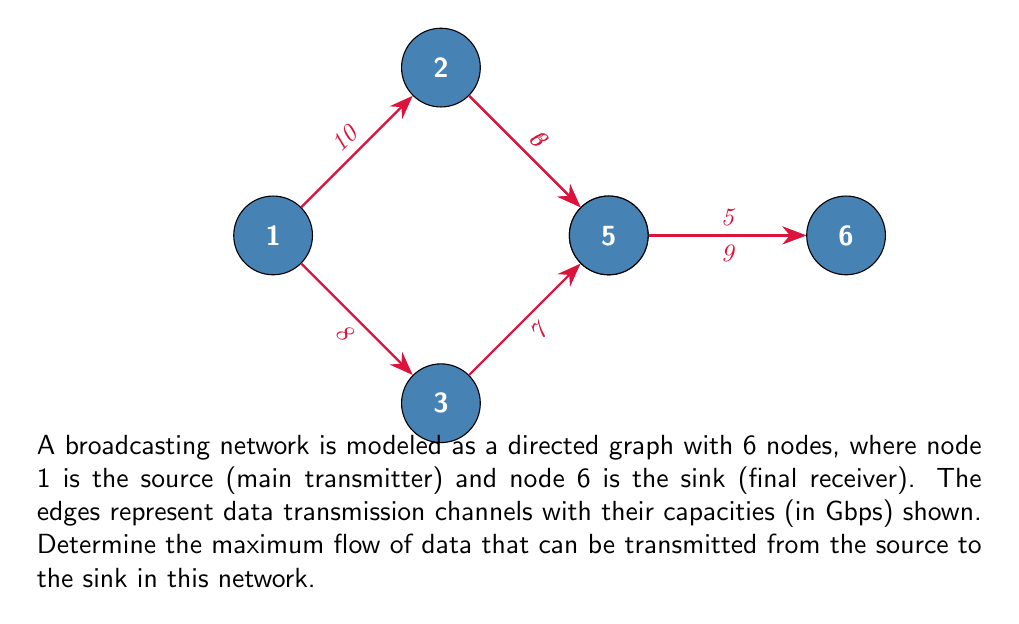Could you help me with this problem? To solve this maximum flow problem, we can use the Ford-Fulkerson algorithm or its improved version, the Edmonds-Karp algorithm. Here's a step-by-step solution:

1) Initialize the flow to 0 for all edges.

2) Find an augmenting path from source to sink. We can use BFS for this (Edmonds-Karp approach). Let's go through the paths:

   Path 1: 1 -> 2 -> 4 -> 6
   Bottleneck: min(10, 6, 5) = 5
   Update flow: 5

   Path 2: 1 -> 2 -> 5 -> 6
   Bottleneck: min(10-5, 3, 9) = 3
   Update flow: 5 + 3 = 8

   Path 3: 1 -> 3 -> 5 -> 6
   Bottleneck: min(8, 7, 9-3) = 6
   Update flow: 8 + 6 = 14

3) No more augmenting paths exist. The maximum flow is 14 Gbps.

To verify:
- Flow out of source: 8 (to node 2) + 6 (to node 3) = 14
- Flow into sink: 5 (from node 4) + 9 (from node 5) = 14

The max-flow min-cut theorem states that the maximum flow is equal to the capacity of the minimum cut. In this case, the minimum cut would be the edges (2,4), (2,5), and (3,5), which have a total capacity of 6 + 3 + 7 = 16 Gbps. Our max flow of 14 Gbps is indeed less than or equal to this cut capacity.
Answer: 14 Gbps 